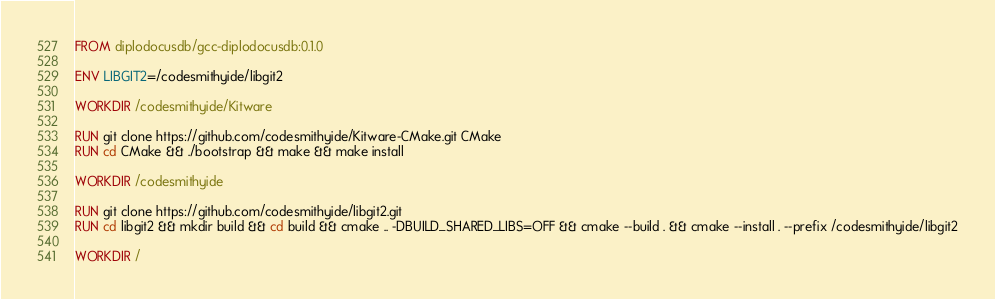Convert code to text. <code><loc_0><loc_0><loc_500><loc_500><_Dockerfile_>FROM diplodocusdb/gcc-diplodocusdb:0.1.0

ENV LIBGIT2=/codesmithyide/libgit2

WORKDIR /codesmithyide/Kitware

RUN git clone https://github.com/codesmithyide/Kitware-CMake.git CMake
RUN cd CMake && ./bootstrap && make && make install

WORKDIR /codesmithyide

RUN git clone https://github.com/codesmithyide/libgit2.git
RUN cd libgit2 && mkdir build && cd build && cmake .. -DBUILD_SHARED_LIBS=OFF && cmake --build . && cmake --install . --prefix /codesmithyide/libgit2

WORKDIR /
</code> 